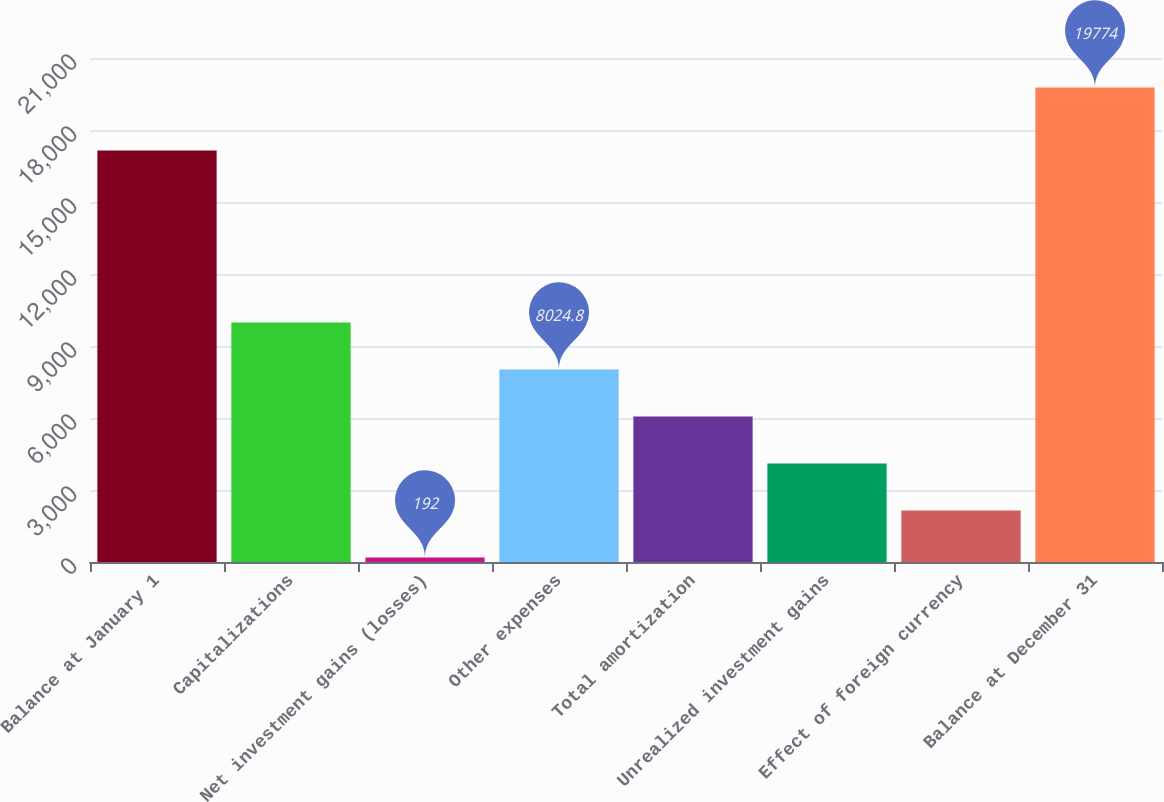Convert chart to OTSL. <chart><loc_0><loc_0><loc_500><loc_500><bar_chart><fcel>Balance at January 1<fcel>Capitalizations<fcel>Net investment gains (losses)<fcel>Other expenses<fcel>Total amortization<fcel>Unrealized investment gains<fcel>Effect of foreign currency<fcel>Balance at December 31<nl><fcel>17150<fcel>9983<fcel>192<fcel>8024.8<fcel>6066.6<fcel>4108.4<fcel>2150.2<fcel>19774<nl></chart> 